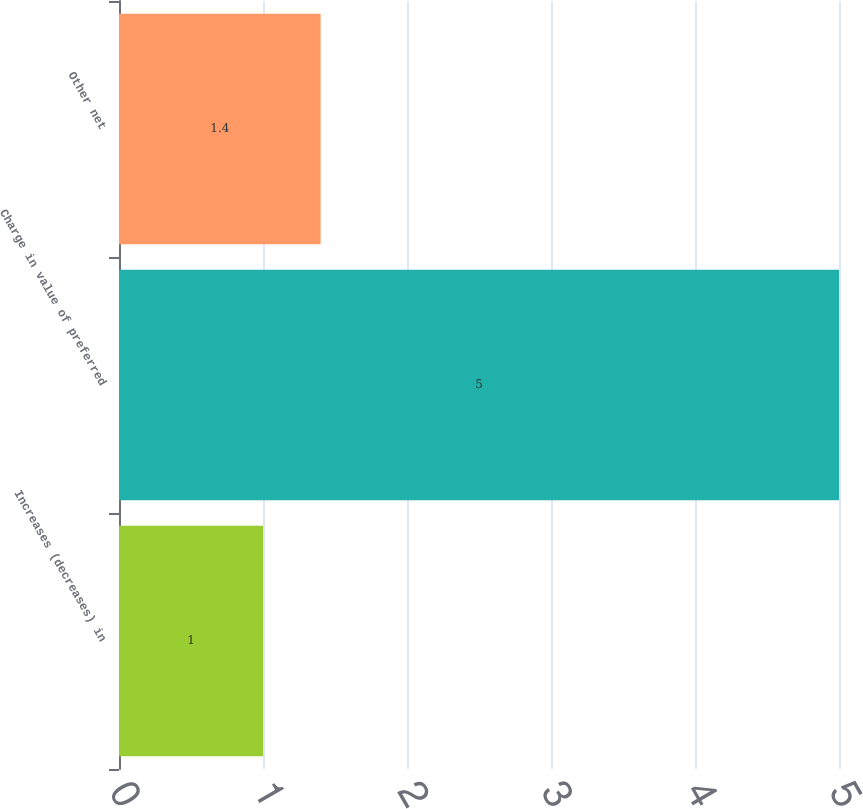Convert chart to OTSL. <chart><loc_0><loc_0><loc_500><loc_500><bar_chart><fcel>Increases (decreases) in<fcel>Charge in value of preferred<fcel>Other net<nl><fcel>1<fcel>5<fcel>1.4<nl></chart> 